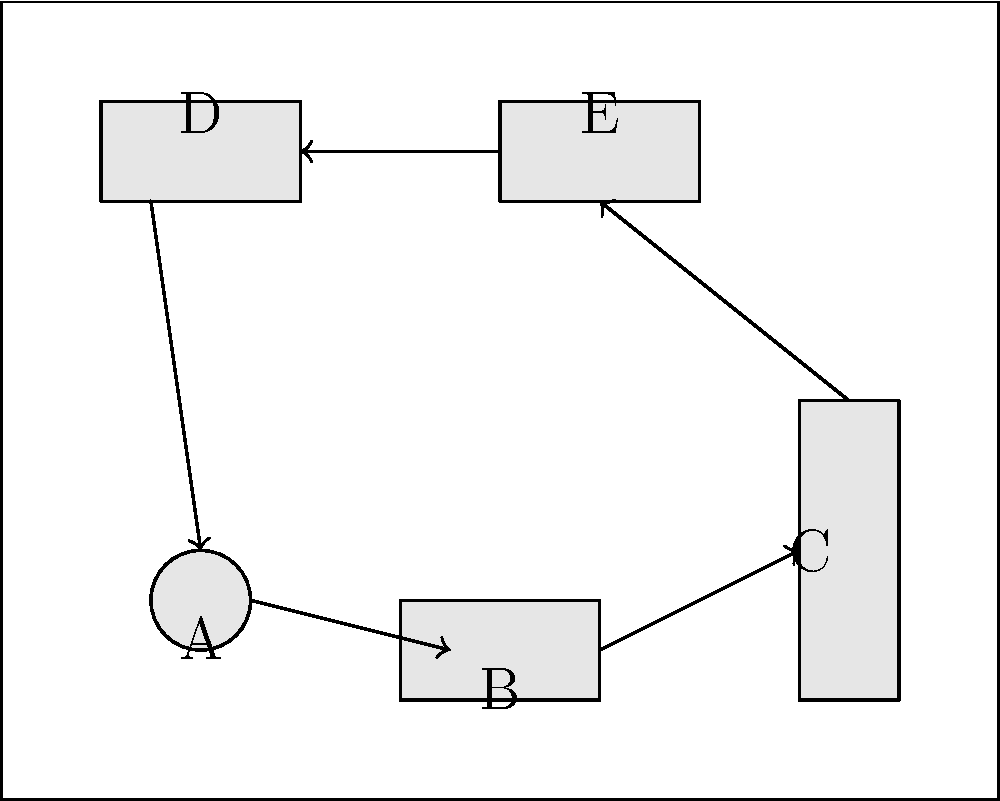As a chef focused on efficient workflow, analyze the kitchen layout diagram. Which sequence of equipment (labeled A to E) represents the most logical and efficient workflow for food preparation and cooking? To determine the most efficient workflow, we need to consider the typical sequence of food preparation and cooking activities:

1. Start with equipment A, which appears to be a round prep table or sink for initial food preparation.
2. Move to equipment B, likely a cutting or preparation station for more detailed work.
3. Equipment C seems to be a large appliance, possibly a stove or oven, where the main cooking would occur.
4. After cooking, dishes might be plated at equipment E, which could be a plating or garnishing station.
5. Finally, equipment D could represent a serving area or pass-through window for finished dishes.

This sequence minimizes unnecessary movement and follows a logical progression from raw ingredients to finished dishes. The arrows in the diagram also support this workflow, showing a clockwise movement through the kitchen.

The most efficient sequence is therefore: A → B → C → E → D
Answer: A-B-C-E-D 